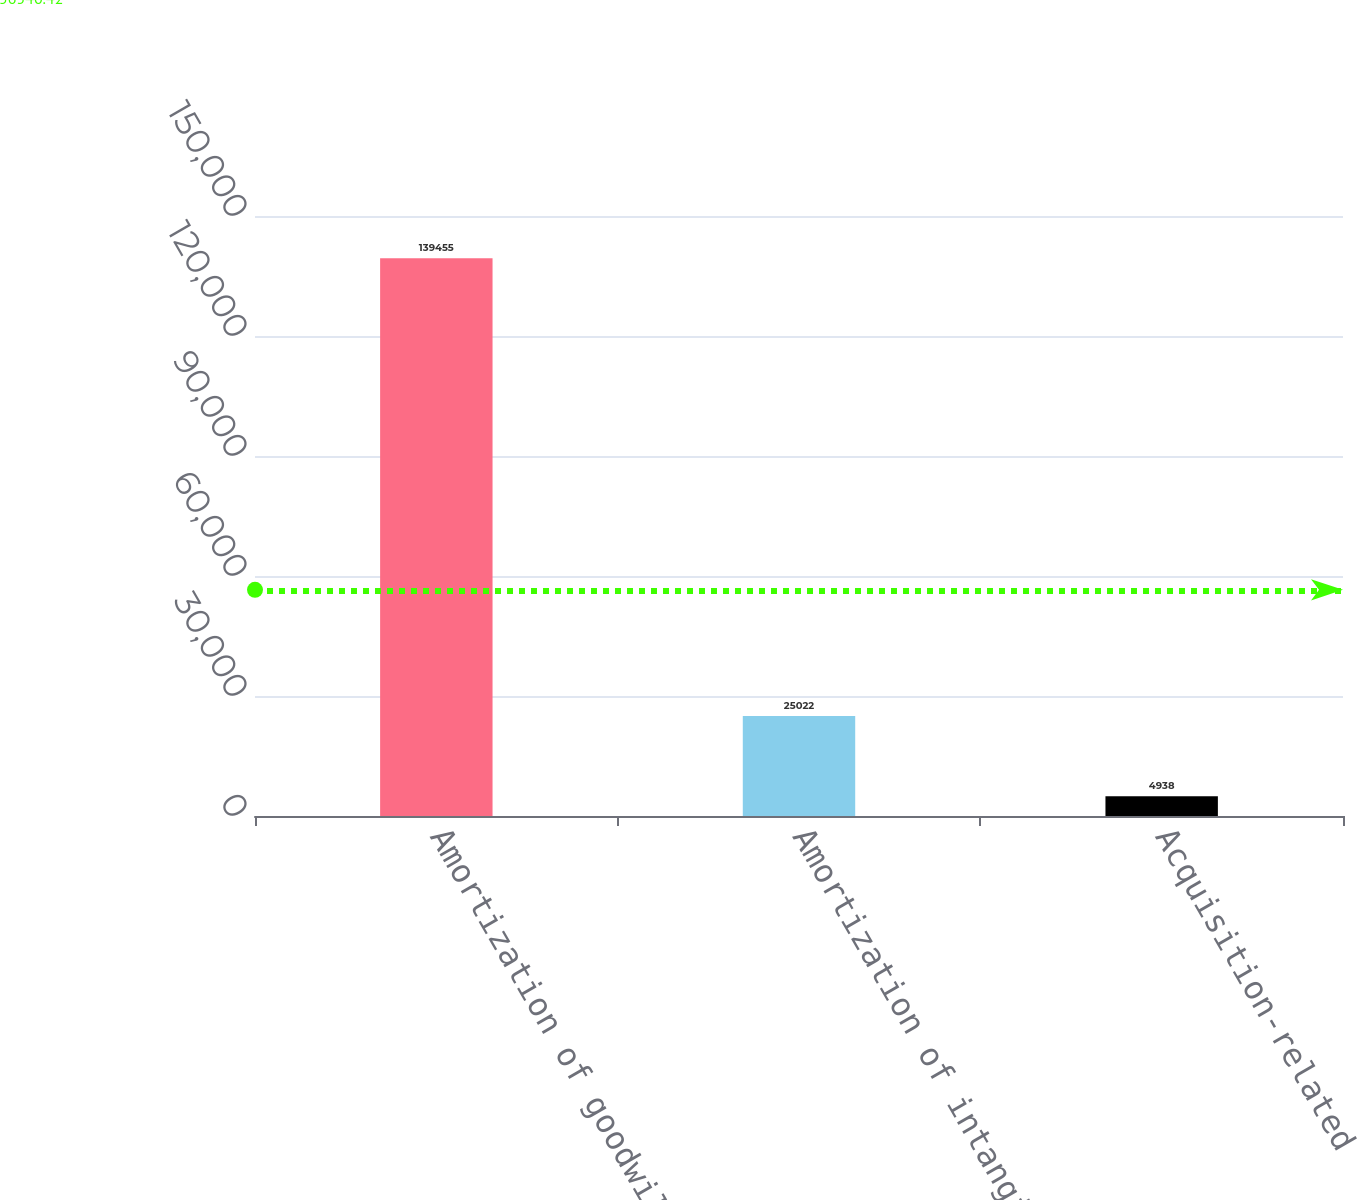Convert chart. <chart><loc_0><loc_0><loc_500><loc_500><bar_chart><fcel>Amortization of goodwill<fcel>Amortization of intangibles<fcel>Acquisition-related<nl><fcel>139455<fcel>25022<fcel>4938<nl></chart> 